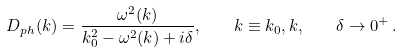<formula> <loc_0><loc_0><loc_500><loc_500>D _ { p h } ( k ) = \frac { \omega ^ { 2 } ( { k } ) } { k _ { 0 } ^ { 2 } - \omega ^ { 2 } ( { k } ) + i \delta } , \quad k \equiv k _ { 0 } , { k } , \quad \delta \to 0 ^ { + } \, .</formula> 